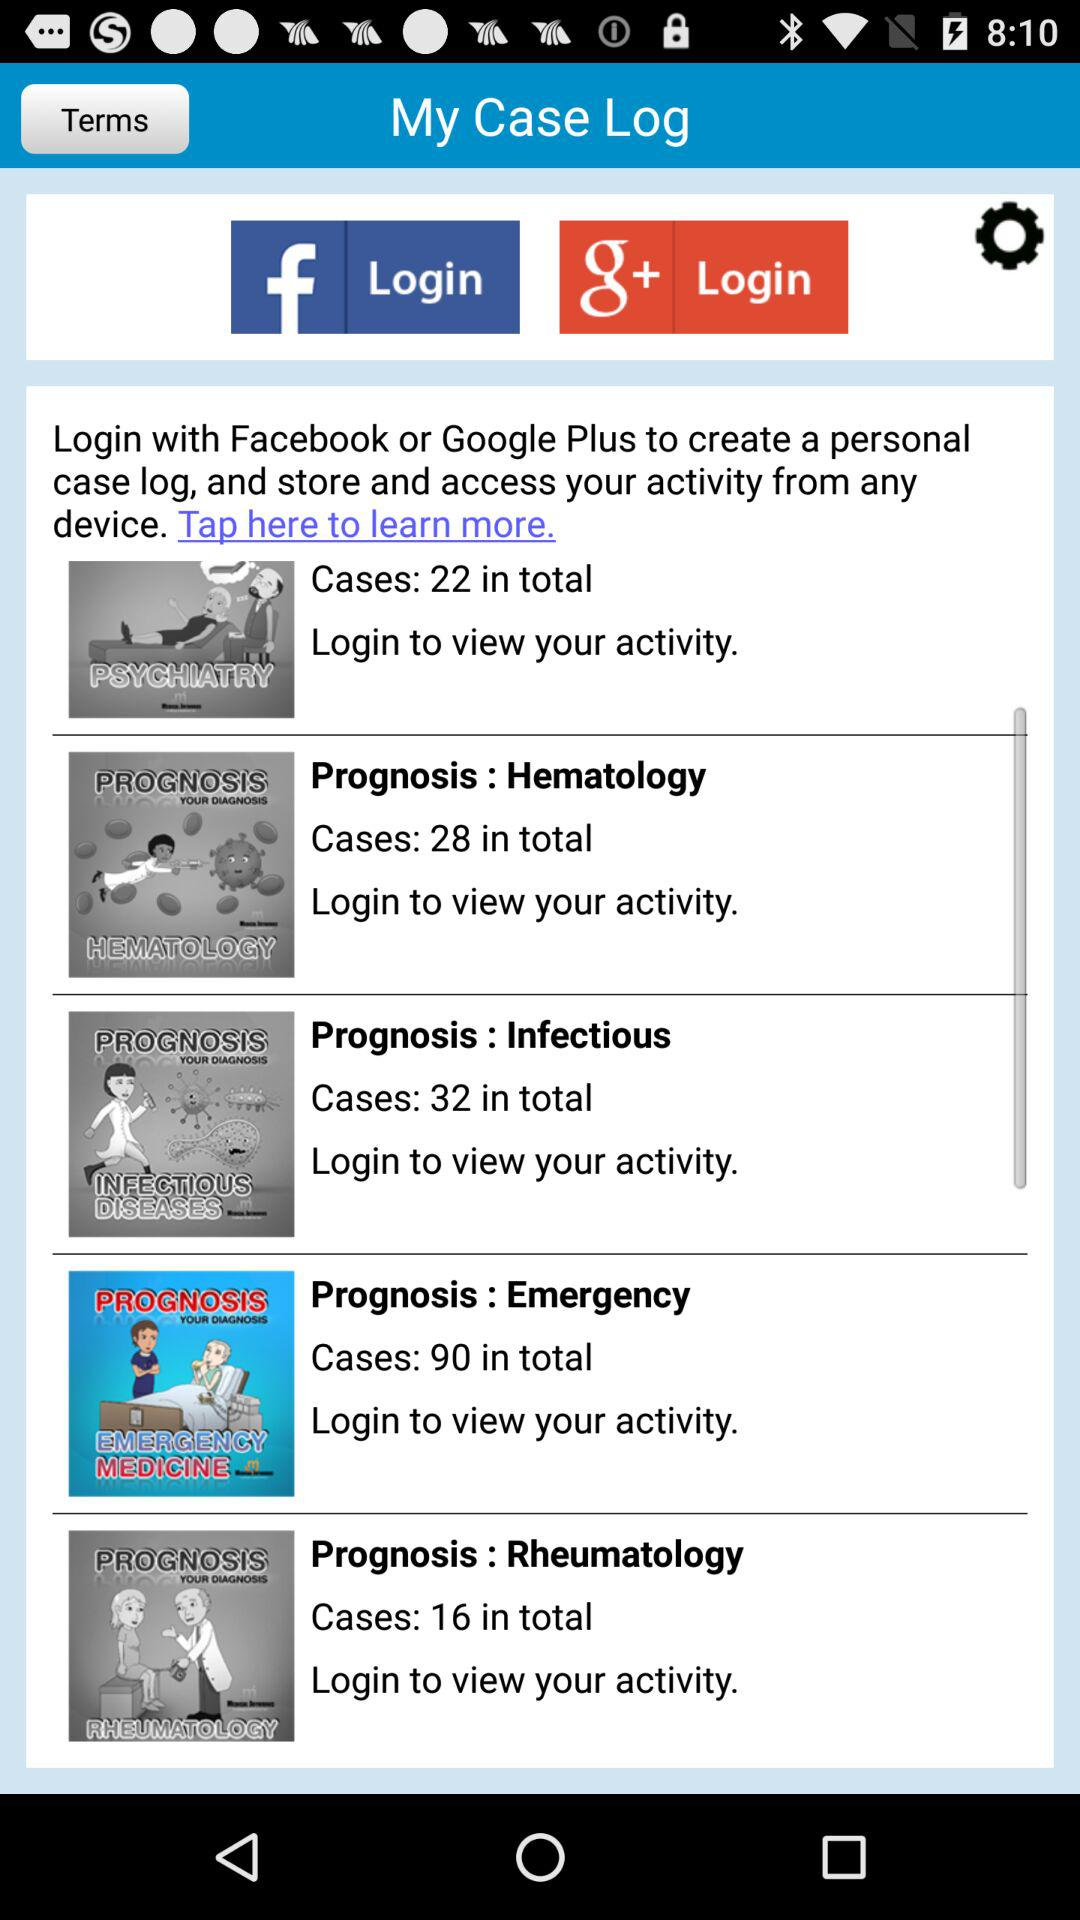What accounts can I use to log in? The accounts that you can use to log in are "Facebook" and "Google+". 